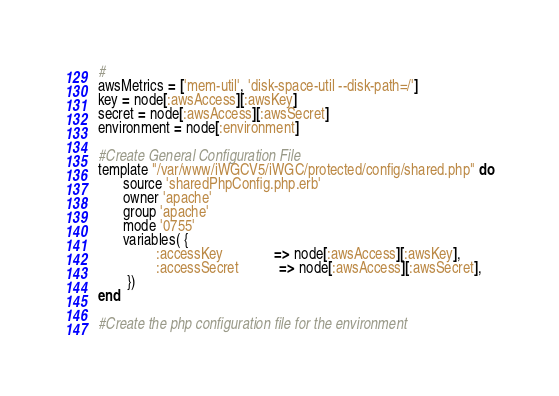<code> <loc_0><loc_0><loc_500><loc_500><_Ruby_>#
awsMetrics = ['mem-util', 'disk-space-util --disk-path=/']
key = node[:awsAccess][:awsKey]
secret = node[:awsAccess][:awsSecret]
environment = node[:environment]

#Create General Configuration File
template "/var/www/iWGCV5/iWGC/protected/config/shared.php" do
       source 'sharedPhpConfig.php.erb'
       owner 'apache'
       group 'apache'
       mode '0755'
       variables( {
                :accessKey              => node[:awsAccess][:awsKey],
                :accessSecret           => node[:awsAccess][:awsSecret],
        })
end

#Create the php configuration file for the environment</code> 